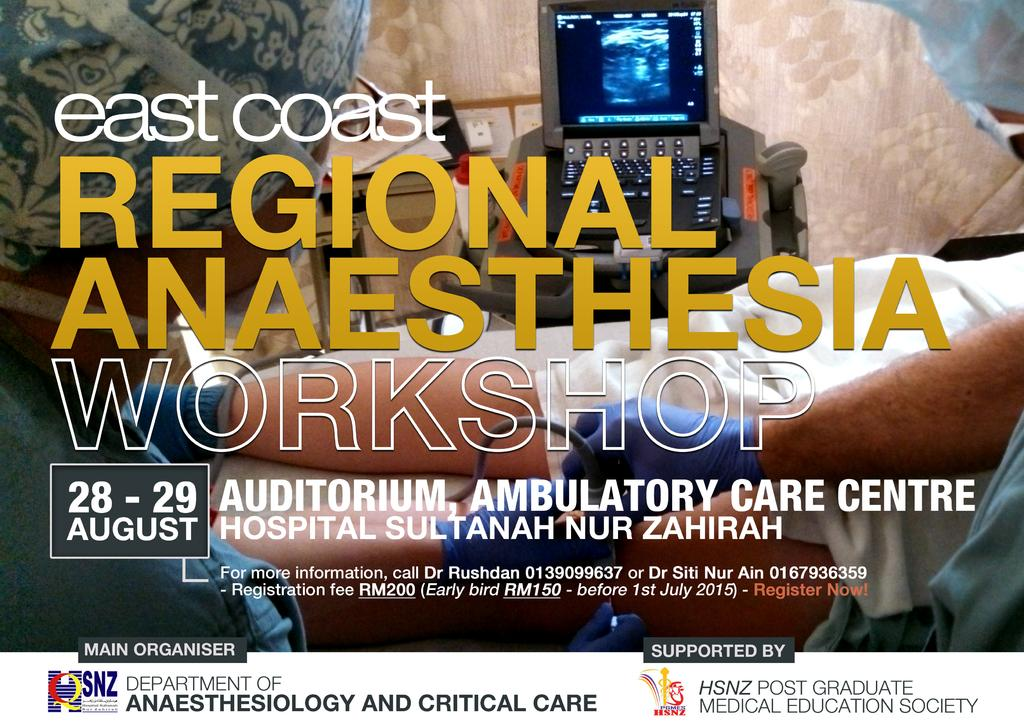<image>
Create a compact narrative representing the image presented. An advert for an east coast anaesthesia workshop 